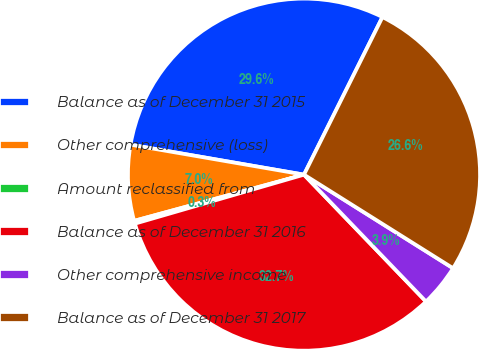Convert chart. <chart><loc_0><loc_0><loc_500><loc_500><pie_chart><fcel>Balance as of December 31 2015<fcel>Other comprehensive (loss)<fcel>Amount reclassified from<fcel>Balance as of December 31 2016<fcel>Other comprehensive income<fcel>Balance as of December 31 2017<nl><fcel>29.63%<fcel>6.95%<fcel>0.26%<fcel>32.7%<fcel>3.89%<fcel>26.57%<nl></chart> 